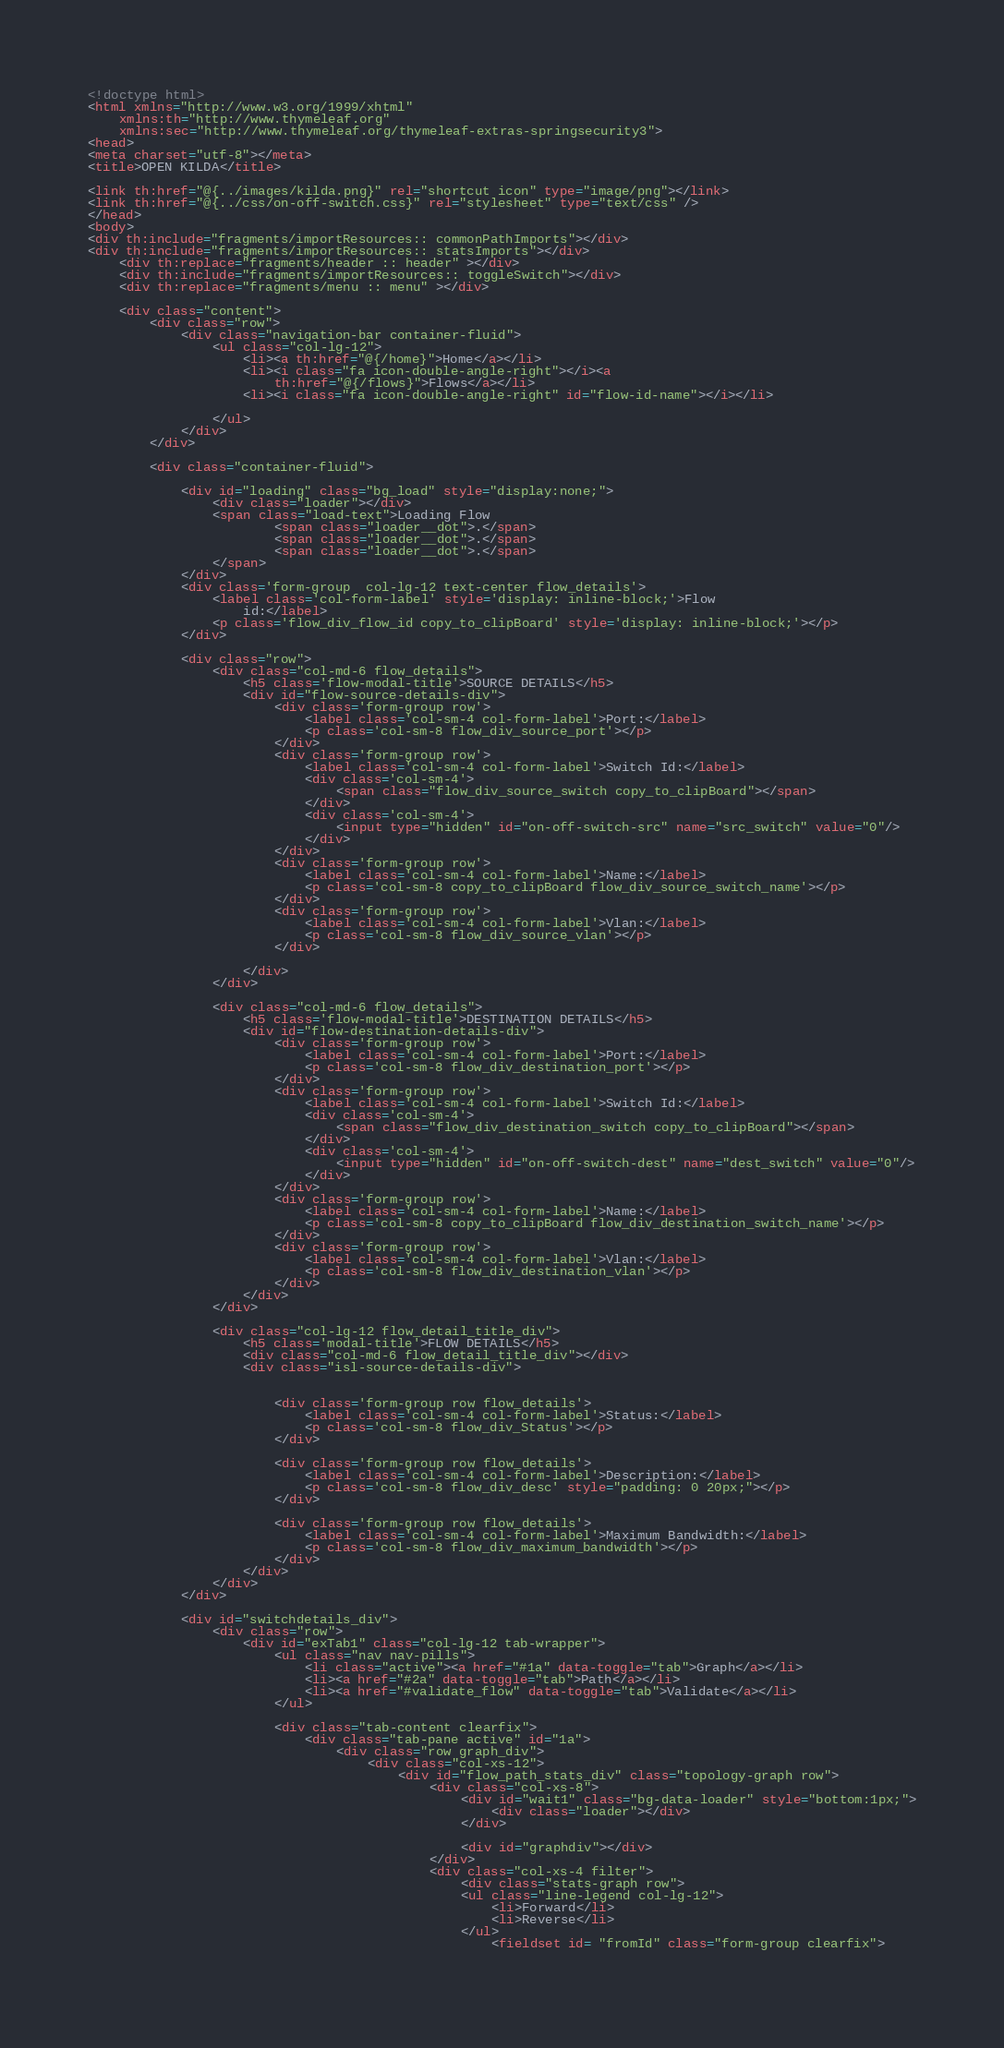<code> <loc_0><loc_0><loc_500><loc_500><_HTML_><!doctype html>
<html xmlns="http://www.w3.org/1999/xhtml"
	xmlns:th="http://www.thymeleaf.org"
	xmlns:sec="http://www.thymeleaf.org/thymeleaf-extras-springsecurity3">
<head>
<meta charset="utf-8"></meta>
<title>OPEN KILDA</title>

<link th:href="@{../images/kilda.png}" rel="shortcut icon" type="image/png"></link>
<link th:href="@{../css/on-off-switch.css}" rel="stylesheet" type="text/css" />
</head>
<body>
<div th:include="fragments/importResources:: commonPathImports"></div>
<div th:include="fragments/importResources:: statsImports"></div>
	<div th:replace="fragments/header :: header" ></div>
	<div th:include="fragments/importResources:: toggleSwitch"></div>
	<div th:replace="fragments/menu :: menu" ></div>

	<div class="content">
		<div class="row">
			<div class="navigation-bar container-fluid">
				<ul class="col-lg-12">
					<li><a th:href="@{/home}">Home</a></li>
					<li><i class="fa icon-double-angle-right"></i><a
						th:href="@{/flows}">Flows</a></li>
					<li><i class="fa icon-double-angle-right" id="flow-id-name"></i></li>

				</ul>
			</div>
		</div>

		<div class="container-fluid">

			<div id="loading" class="bg_load" style="display:none;">
				<div class="loader"></div>
				<span class="load-text">Loading Flow
						<span class="loader__dot">.</span>
  			  			<span class="loader__dot">.</span>
  			 			<span class="loader__dot">.</span>
  			 	</span>  
			</div>
			<div class='form-group  col-lg-12 text-center flow_details'>
				<label class='col-form-label' style='display: inline-block;'>Flow
					id:</label>
				<p class='flow_div_flow_id copy_to_clipBoard' style='display: inline-block;'></p>
			</div>
			
			<div class="row">
				<div class="col-md-6 flow_details">
					<h5 class='flow-modal-title'>SOURCE DETAILS</h5>
					<div id="flow-source-details-div">
						<div class='form-group row'>
							<label class='col-sm-4 col-form-label'>Port:</label>
							<p class='col-sm-8 flow_div_source_port'></p>
						</div>
						<div class='form-group row'>
							<label class='col-sm-4 col-form-label'>Switch Id:</label>
							<div class='col-sm-4'>
								<span class="flow_div_source_switch copy_to_clipBoard"></span>
							</div>
							<div class='col-sm-4'>	
								<input type="hidden" id="on-off-switch-src" name="src_switch" value="0"/>
							</div>
						</div>
						<div class='form-group row'>
							<label class='col-sm-4 col-form-label'>Name:</label>
							<p class='col-sm-8 copy_to_clipBoard flow_div_source_switch_name'></p>
						</div>
						<div class='form-group row'>
							<label class='col-sm-4 col-form-label'>Vlan:</label>
							<p class='col-sm-8 flow_div_source_vlan'></p>
						</div>
	
					</div>
				</div>
	
				<div class="col-md-6 flow_details">
					<h5 class='flow-modal-title'>DESTINATION DETAILS</h5>
					<div id="flow-destination-details-div">
						<div class='form-group row'>
							<label class='col-sm-4 col-form-label'>Port:</label>
							<p class='col-sm-8 flow_div_destination_port'></p>
						</div>
						<div class='form-group row'>
							<label class='col-sm-4 col-form-label'>Switch Id:</label>
							<div class='col-sm-4'>
								<span class="flow_div_destination_switch copy_to_clipBoard"></span>
							</div>
							<div class='col-sm-4'>	
								<input type="hidden" id="on-off-switch-dest" name="dest_switch" value="0"/>
							</div>
						</div>
						<div class='form-group row'>
							<label class='col-sm-4 col-form-label'>Name:</label>
							<p class='col-sm-8 copy_to_clipBoard flow_div_destination_switch_name'></p>
						</div>
						<div class='form-group row'>
							<label class='col-sm-4 col-form-label'>Vlan:</label>
							<p class='col-sm-8 flow_div_destination_vlan'></p>
						</div>
					</div>
				</div>
	
				<div class="col-lg-12 flow_detail_title_div">
					<h5 class='modal-title'>FLOW DETAILS</h5>
					<div class="col-md-6 flow_detail_title_div"></div>
					<div class="isl-source-details-div">
	
	
						<div class='form-group row flow_details'>
							<label class='col-sm-4 col-form-label'>Status:</label>
							<p class='col-sm-8 flow_div_Status'></p>
						</div>
	
						<div class='form-group row flow_details'>
							<label class='col-sm-4 col-form-label'>Description:</label>
							<p class='col-sm-8 flow_div_desc' style="padding: 0 20px;"></p>
						</div>
	
						<div class='form-group row flow_details'>
							<label class='col-sm-4 col-form-label'>Maximum Bandwidth:</label>
							<p class='col-sm-8 flow_div_maximum_bandwidth'></p>
						</div>
					</div>
				</div>
			</div>

			<div id="switchdetails_div">
				<div class="row">
					<div id="exTab1" class="col-lg-12 tab-wrapper">
						<ul class="nav nav-pills">
							<li class="active"><a href="#1a" data-toggle="tab">Graph</a></li>
							<li><a href="#2a" data-toggle="tab">Path</a></li>
							<li><a href="#validate_flow" data-toggle="tab">Validate</a></li>
						</ul>

						<div class="tab-content clearfix">
							<div class="tab-pane active" id="1a">
								<div class="row graph_div">
									<div class="col-xs-12">
										<div id="flow_path_stats_div" class="topology-graph row">
											<div class="col-xs-8">
												<div id="wait1" class="bg-data-loader" style="bottom:1px;">
													<div class="loader"></div>
												</div>
											
												<div id="graphdiv"></div>
											</div>
											<div class="col-xs-4 filter">
												<div class="stats-graph row">
												<ul class="line-legend col-lg-12">
												 	<li>Forward</li>
												  	<li>Reverse</li>
												</ul>
													<fieldset id= "fromId" class="form-group clearfix">
													</code> 